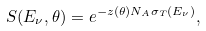Convert formula to latex. <formula><loc_0><loc_0><loc_500><loc_500>S ( E _ { \nu } , \theta ) = e ^ { - z ( \theta ) N _ { A } \sigma _ { T } ( E _ { \nu } ) } ,</formula> 